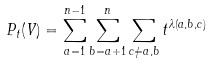Convert formula to latex. <formula><loc_0><loc_0><loc_500><loc_500>P _ { t } ( V ) = \sum _ { a = 1 } ^ { n - 1 } \sum _ { b = a + 1 } ^ { n } \sum _ { c \neq a , b } t ^ { \lambda ( a , b , c ) }</formula> 